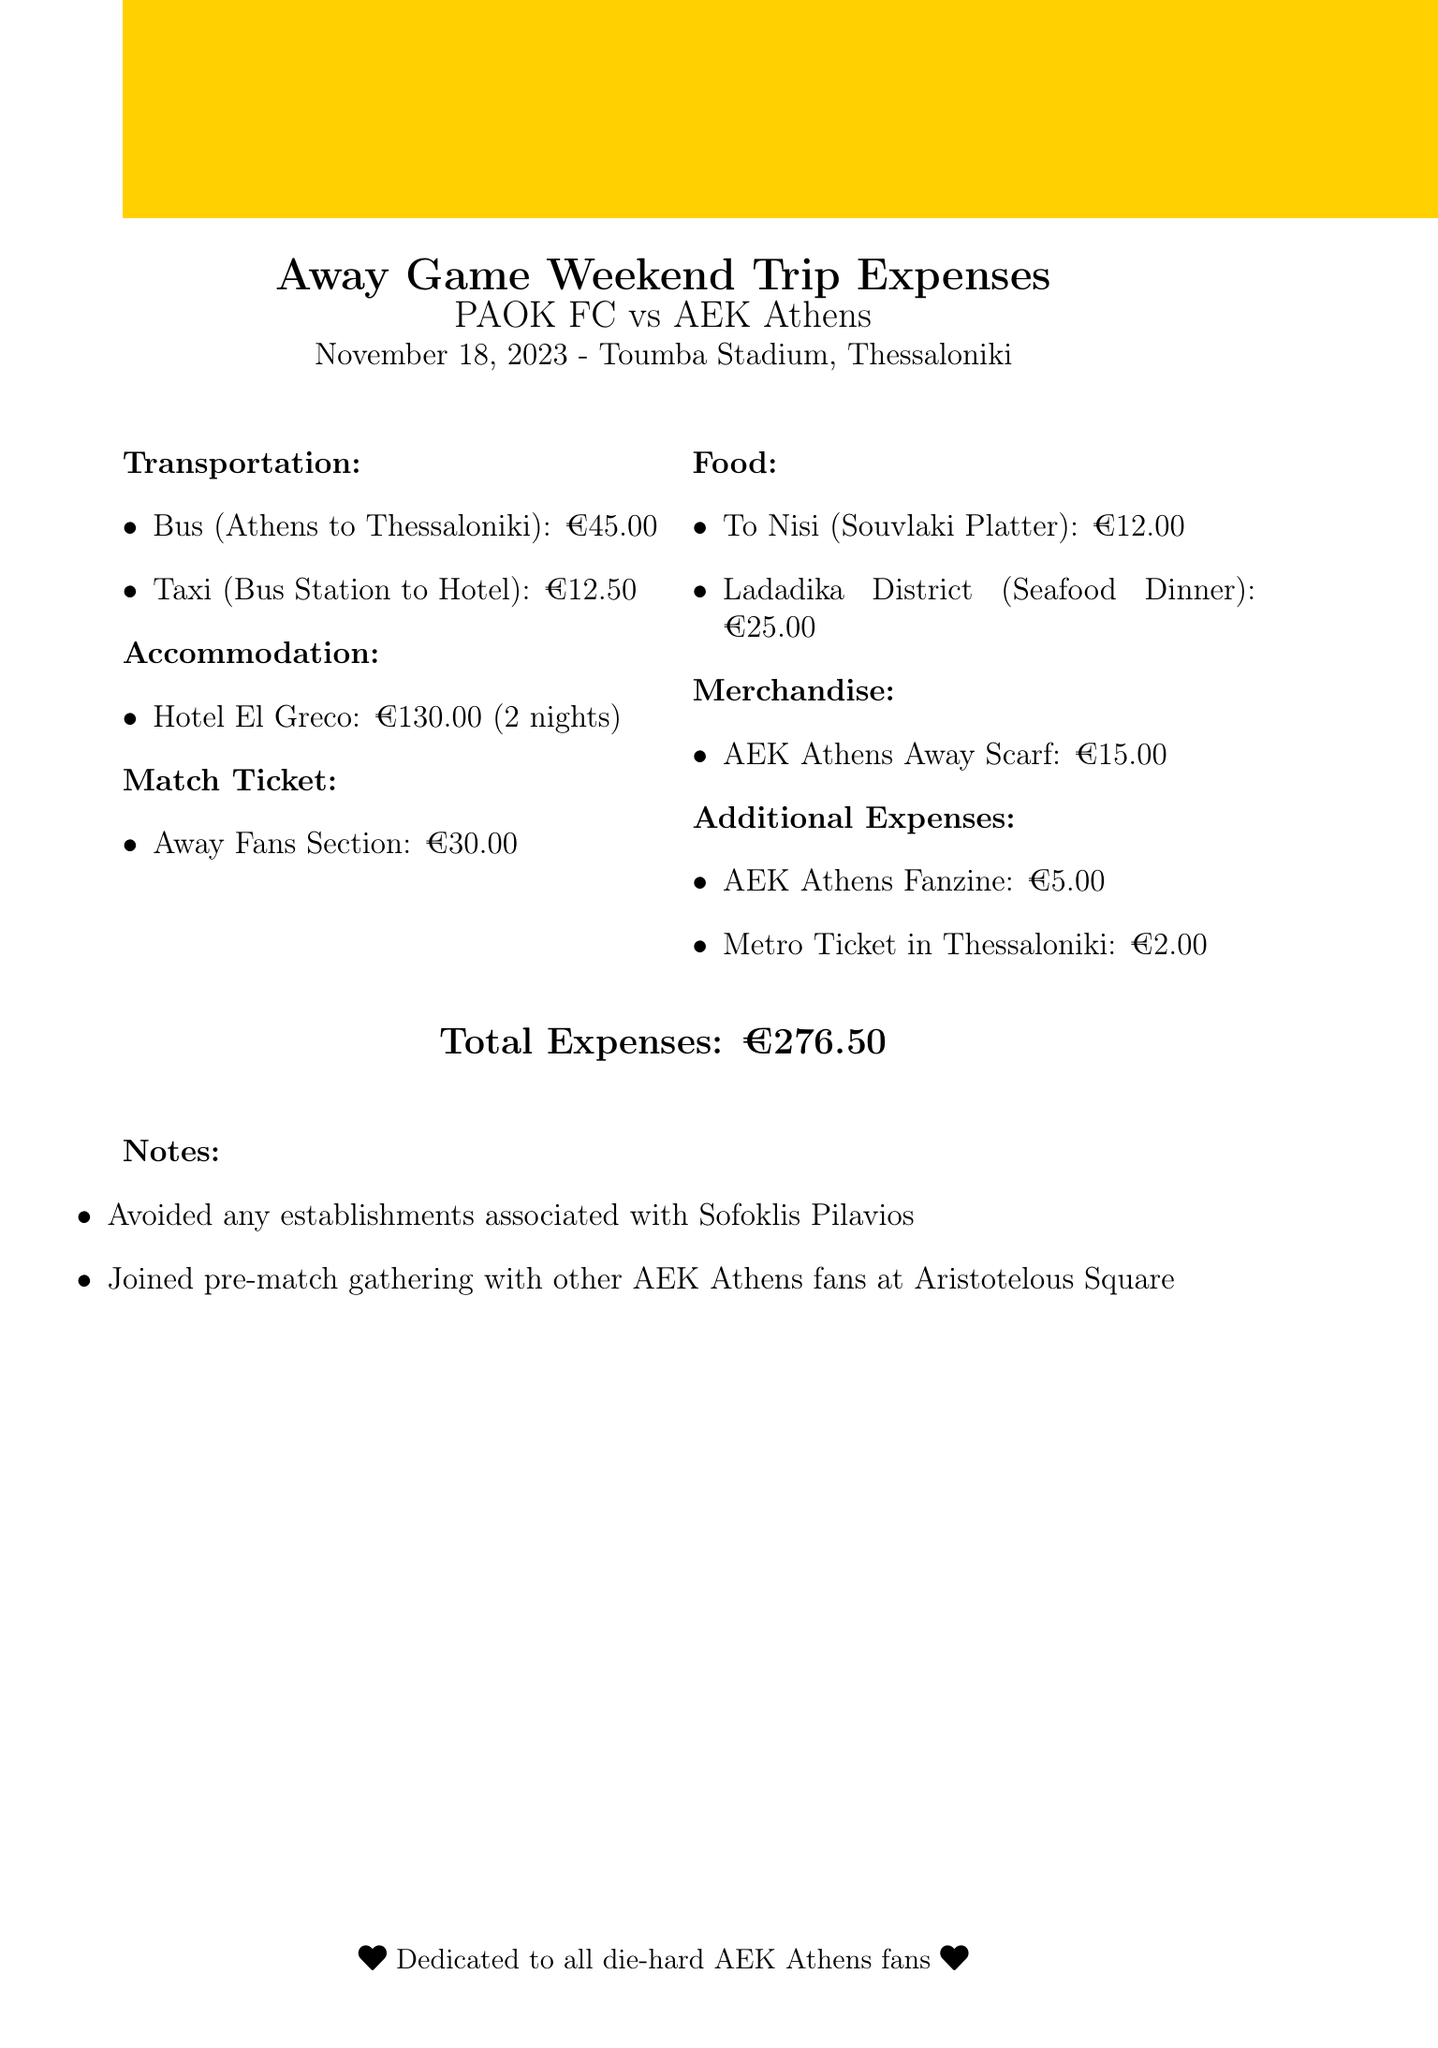What is the destination of the trip? The destination of the trip is mentioned in the trip details section of the document.
Answer: Thessaloniki How much did the bus ticket cost? The cost of the bus ticket from Athens to Thessaloniki is listed under the transportation section.
Answer: 45.00 What type of room was booked for accommodation? The type of room for accommodation is provided in the accommodation details of the document.
Answer: Double Room How many nights was the stay at the hotel? The number of nights for the hotel stay is specified in the accommodation section.
Answer: 2 What was the price of the match ticket? The price for the match ticket is detailed in the match tickets section of the document.
Answer: 30.00 What is the total amount spent on this trip? The total expenses are calculated and presented at the end of the document.
Answer: 276.50 Which team are AEK Athens playing against? The away team that AEK Athens is playing against is stated in the trip details section.
Answer: PAOK FC What item was purchased as merchandise? The specific merchandise item purchased is included in the merchandise section.
Answer: AEK Athens Away Scarf What note was made regarding Sofoklis Pilavios? The notes section includes a specific note about avoiding establishments related to Sofoklis Pilavios.
Answer: Avoided any establishments associated with Sofoklis Pilavios 